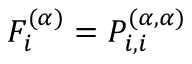Convert formula to latex. <formula><loc_0><loc_0><loc_500><loc_500>{ F _ { i } ^ { ( \alpha ) } = P _ { i , i } ^ { ( \alpha , \alpha ) } }</formula> 